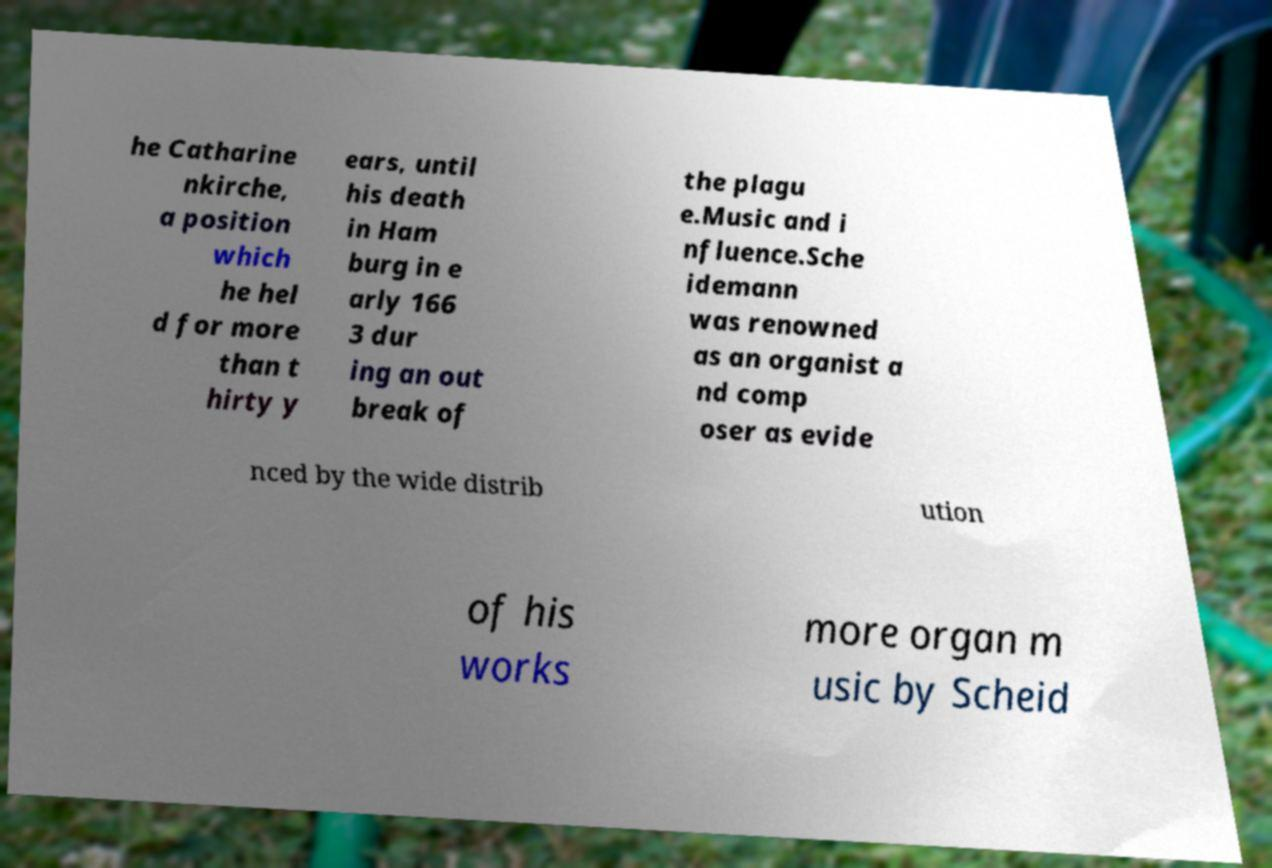For documentation purposes, I need the text within this image transcribed. Could you provide that? he Catharine nkirche, a position which he hel d for more than t hirty y ears, until his death in Ham burg in e arly 166 3 dur ing an out break of the plagu e.Music and i nfluence.Sche idemann was renowned as an organist a nd comp oser as evide nced by the wide distrib ution of his works more organ m usic by Scheid 